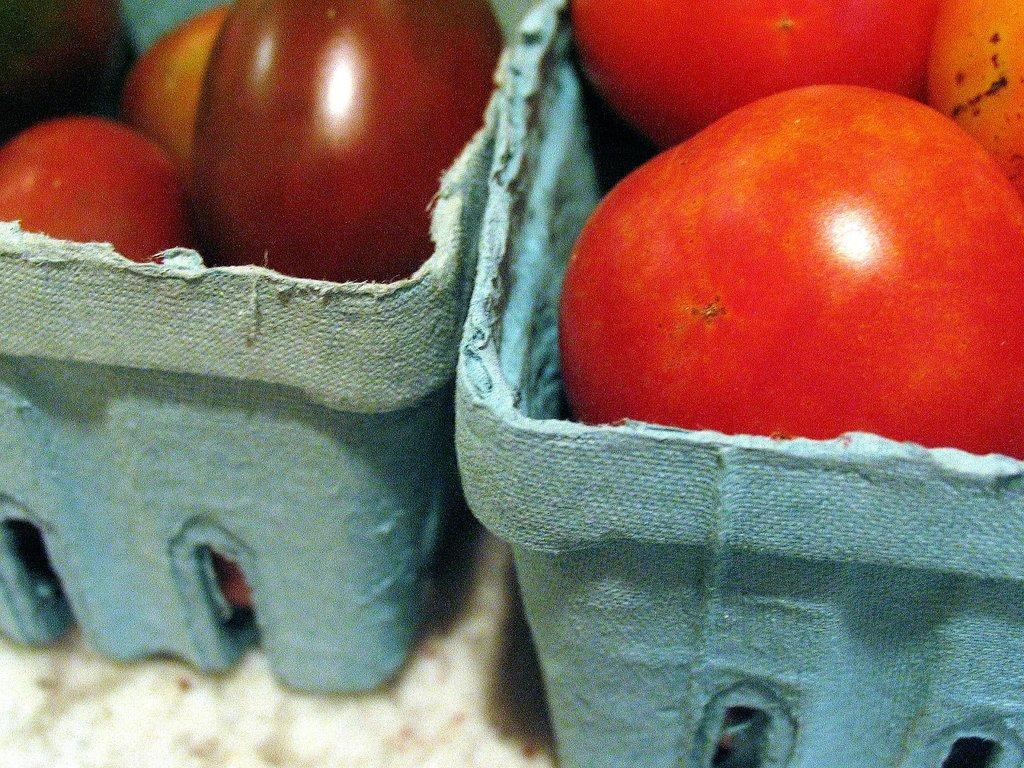What type of food items are present in the image? There are vegetables in the image. How are the vegetables arranged or stored in the image? The vegetables are in baskets. Where are the baskets with vegetables located in the image? The baskets are placed on a surface. What type of toys can be seen in the image? There are no toys present in the image; it features vegetables in baskets placed on a surface. What type of punishment is being administered in the image? There is no punishment being administered in the image; it features vegetables in baskets placed on a surface. 